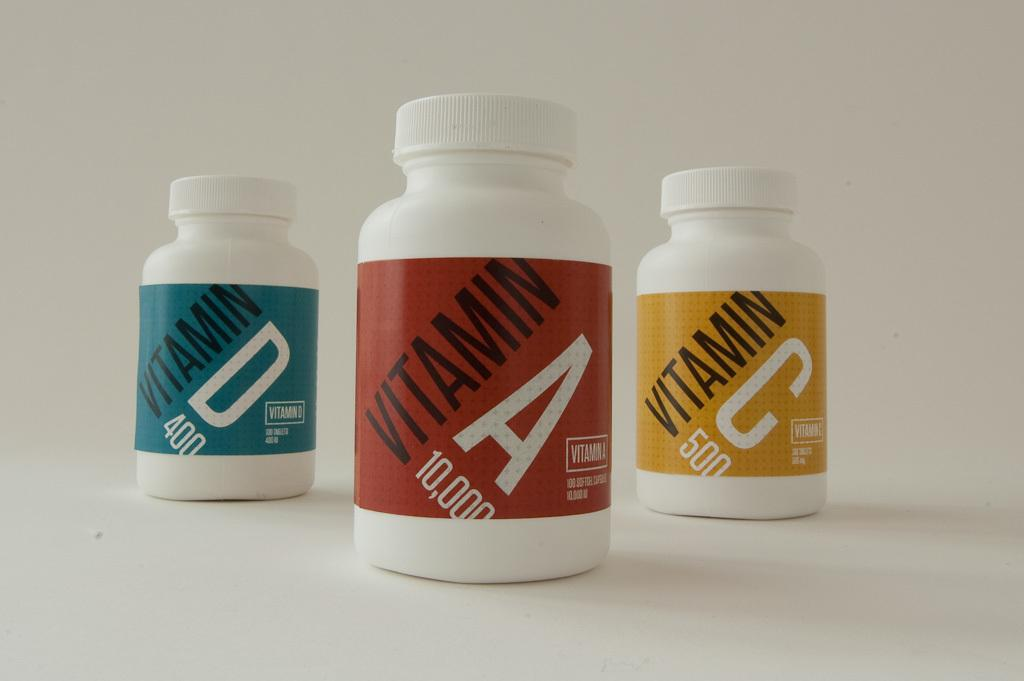Provide a one-sentence caption for the provided image. Three pill bottleswith vitamins A, C and D in them. 